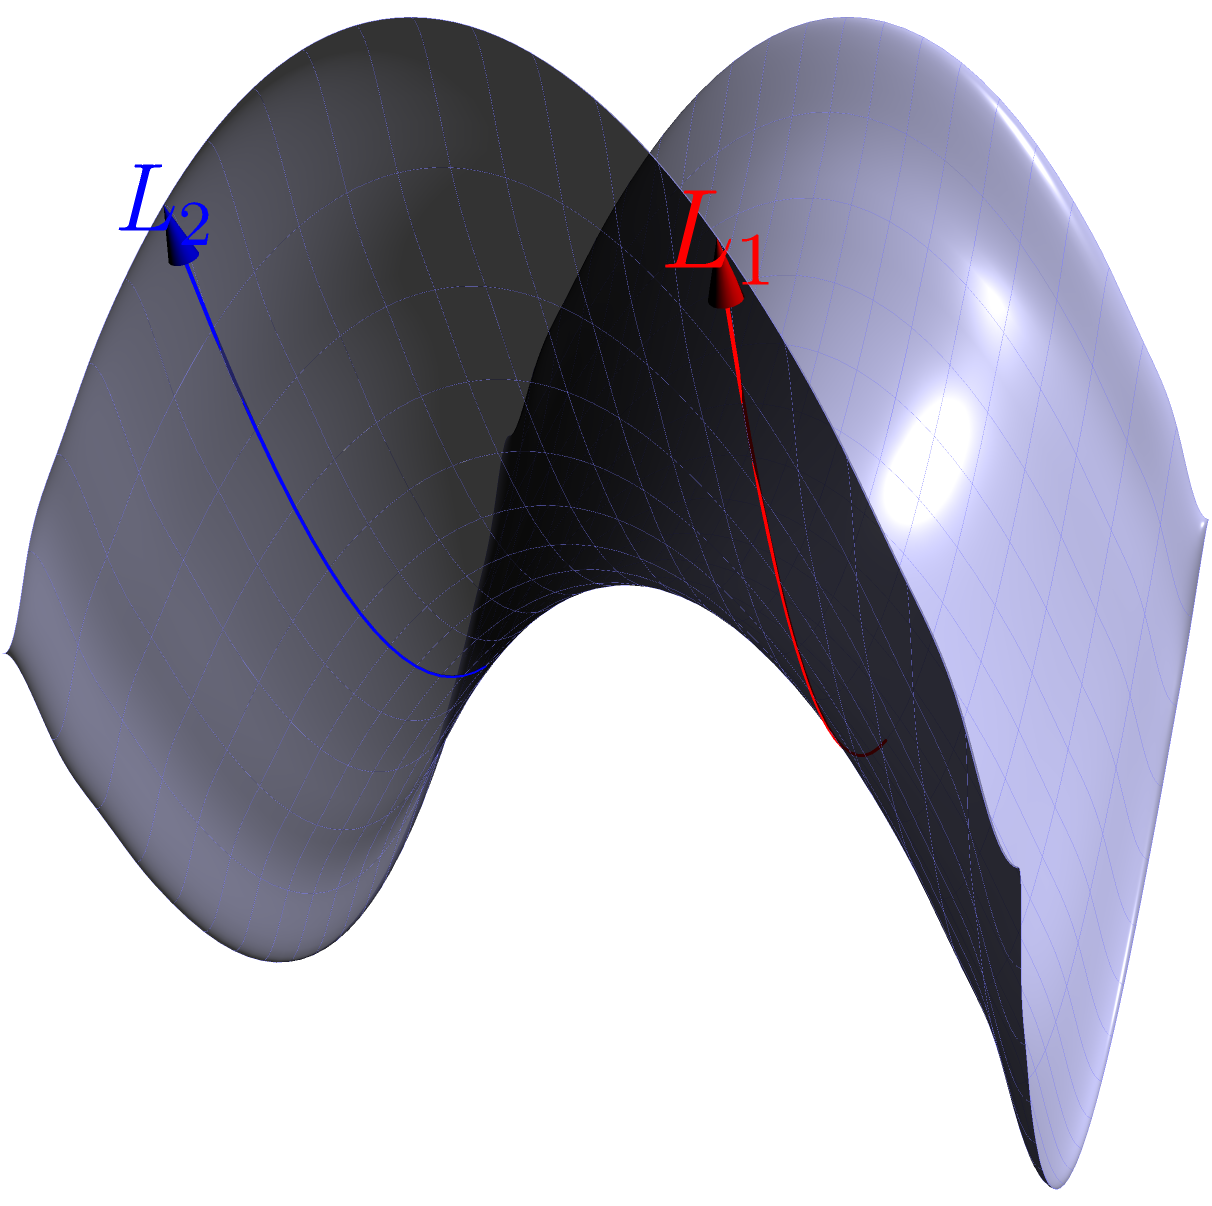On a saddle-shaped surface reminiscent of a breaking wave, two parallel lines $L_1$ and $L_2$ are drawn as shown in the figure. If these lines start parallel at $x=0$, what happens to their relative positions as they progress along the surface? To understand the behavior of parallel lines on a saddle-shaped surface, let's follow these steps:

1) The saddle surface is described by the equation $z = \frac{1}{2}(x^2 - y^2)$. This shape is similar to the curved face of a breaking wave.

2) The two lines $L_1$ and $L_2$ are drawn at $y=1$ and $y=-1$ respectively, both starting at $x=0$.

3) At $x=0$, both lines are parallel and have the same $z$-coordinate: 
   $z = \frac{1}{2}(0^2 - 1^2) = -\frac{1}{2}$

4) As $x$ increases, the $z$-coordinates of the lines change:
   For $L_1$: $z = \frac{1}{2}(x^2 - 1^2)$
   For $L_2$: $z = \frac{1}{2}(x^2 - (-1)^2) = \frac{1}{2}(x^2 - 1)$

5) Note that these equations are identical, meaning the lines maintain the same relative height as they progress.

6) However, due to the curvature of the surface, the lines appear to diverge when viewed from above, despite maintaining their relative positions in 3D space.

7) This phenomenon is a key principle in Non-Euclidean geometry, specifically hyperbolic geometry, where parallel lines appear to diverge.
Answer: The lines maintain constant vertical separation but appear to diverge when viewed from above. 